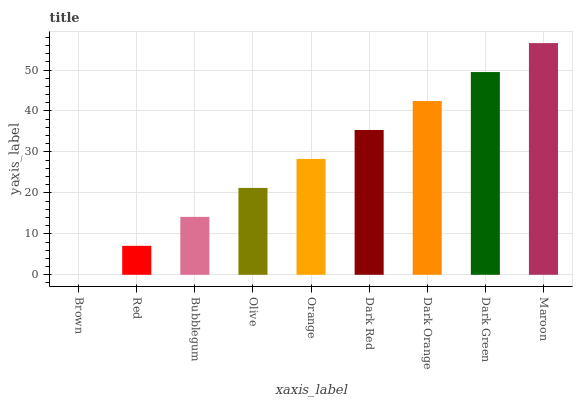Is Brown the minimum?
Answer yes or no. Yes. Is Maroon the maximum?
Answer yes or no. Yes. Is Red the minimum?
Answer yes or no. No. Is Red the maximum?
Answer yes or no. No. Is Red greater than Brown?
Answer yes or no. Yes. Is Brown less than Red?
Answer yes or no. Yes. Is Brown greater than Red?
Answer yes or no. No. Is Red less than Brown?
Answer yes or no. No. Is Orange the high median?
Answer yes or no. Yes. Is Orange the low median?
Answer yes or no. Yes. Is Dark Orange the high median?
Answer yes or no. No. Is Dark Orange the low median?
Answer yes or no. No. 